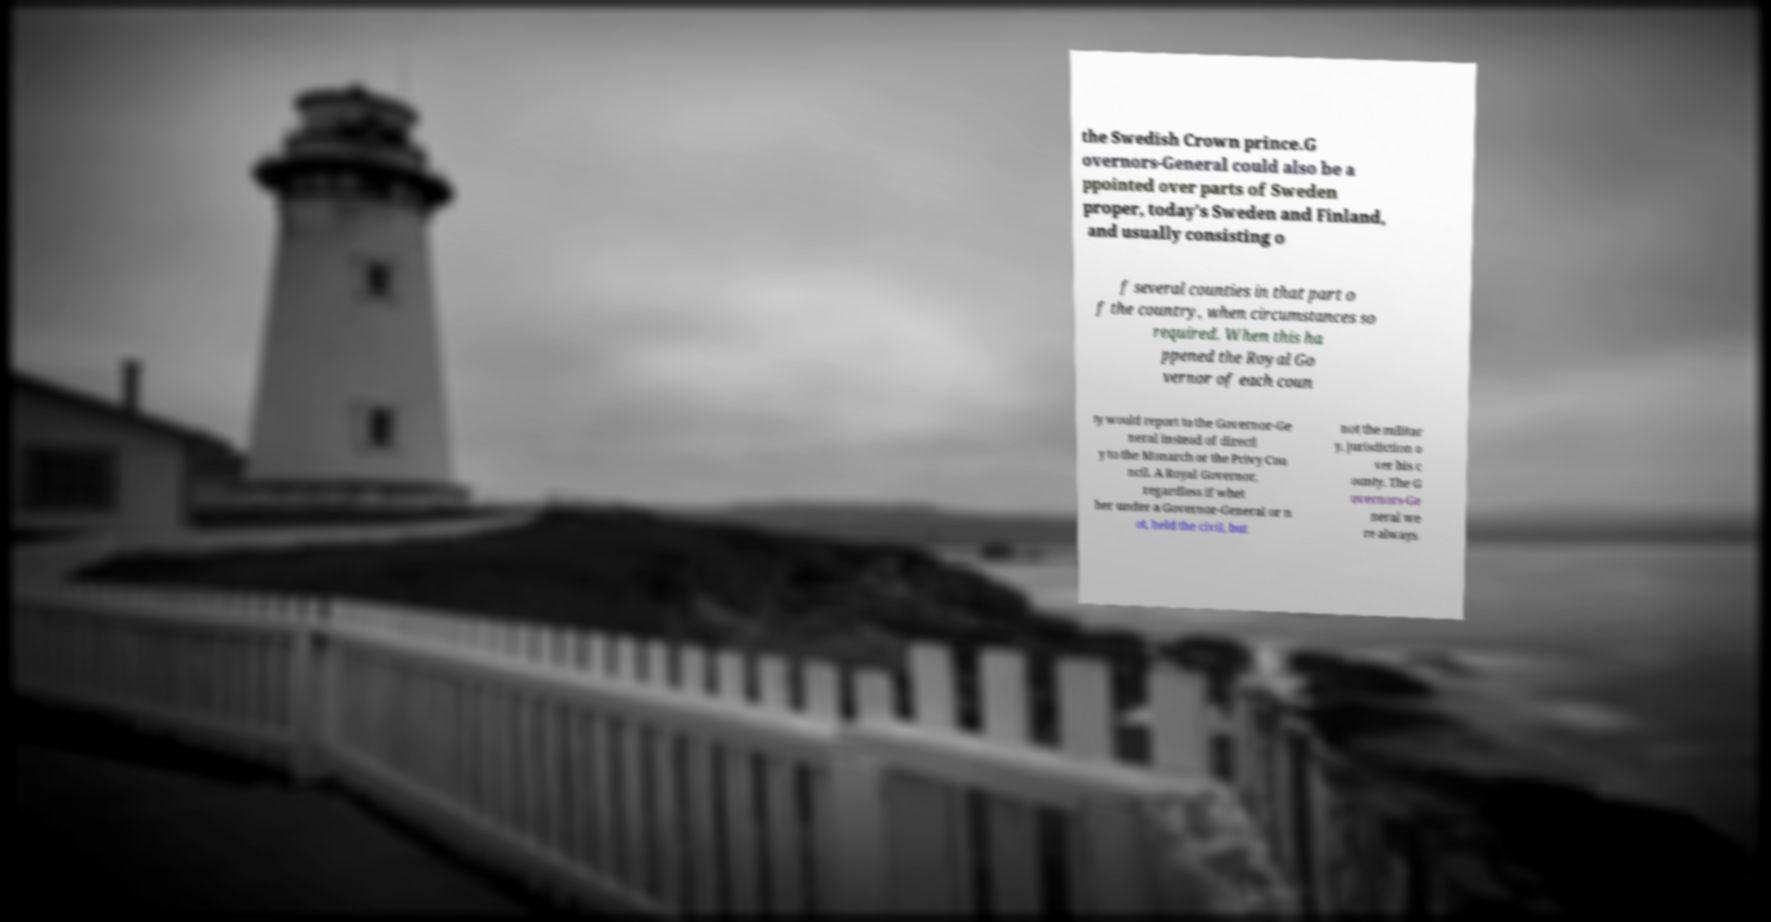Please identify and transcribe the text found in this image. the Swedish Crown prince.G overnors-General could also be a ppointed over parts of Sweden proper, today's Sweden and Finland, and usually consisting o f several counties in that part o f the country, when circumstances so required. When this ha ppened the Royal Go vernor of each coun ty would report to the Governor-Ge neral instead of directl y to the Monarch or the Privy Cou ncil. A Royal Governor, regardless if whet her under a Governor-General or n ot, held the civil, but not the militar y, jurisdiction o ver his c ounty. The G overnors-Ge neral we re always 